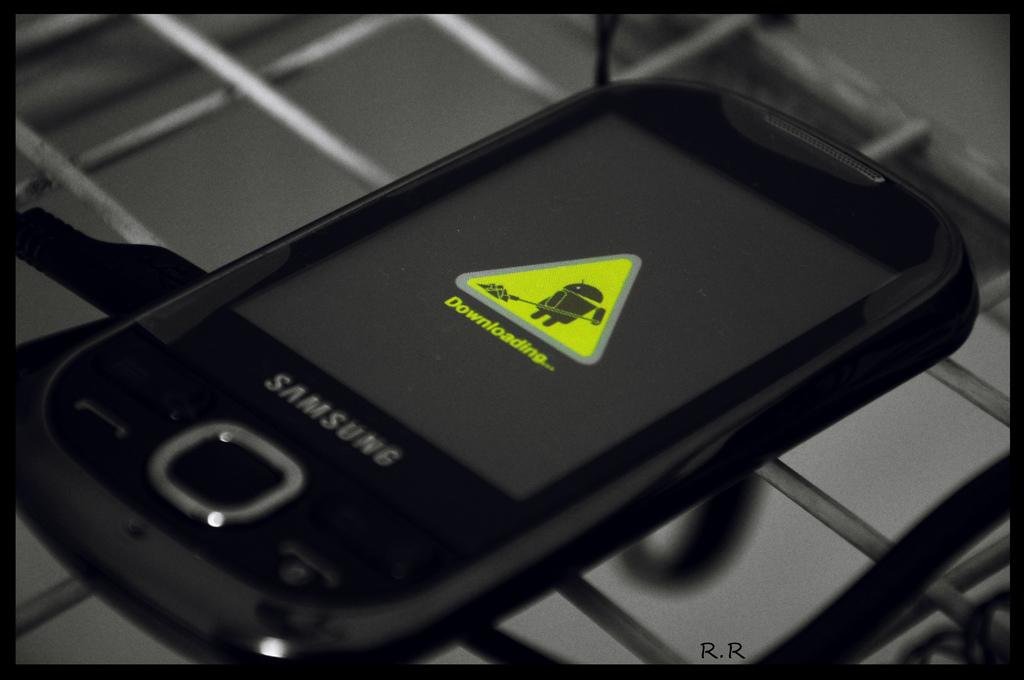What is the brand of this smartphone?
Your answer should be compact. Samsung. What is the phone doing?
Keep it short and to the point. Downloading. 